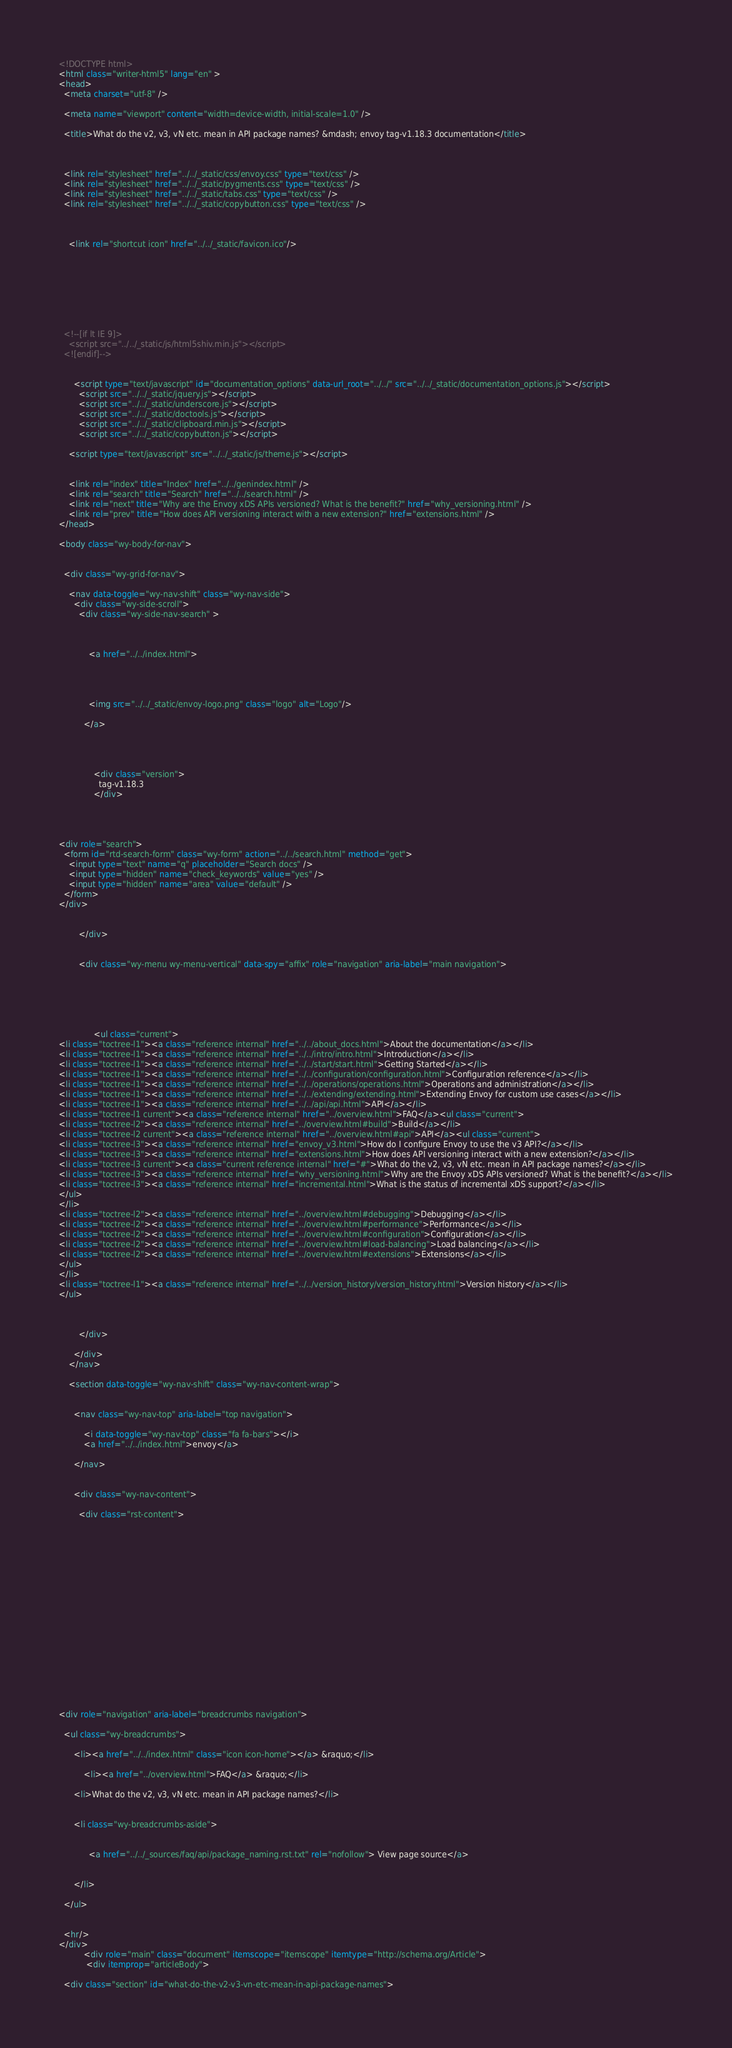<code> <loc_0><loc_0><loc_500><loc_500><_HTML_>

<!DOCTYPE html>
<html class="writer-html5" lang="en" >
<head>
  <meta charset="utf-8" />
  
  <meta name="viewport" content="width=device-width, initial-scale=1.0" />
  
  <title>What do the v2, v3, vN etc. mean in API package names? &mdash; envoy tag-v1.18.3 documentation</title>
  

  
  <link rel="stylesheet" href="../../_static/css/envoy.css" type="text/css" />
  <link rel="stylesheet" href="../../_static/pygments.css" type="text/css" />
  <link rel="stylesheet" href="../../_static/tabs.css" type="text/css" />
  <link rel="stylesheet" href="../../_static/copybutton.css" type="text/css" />

  
  
    <link rel="shortcut icon" href="../../_static/favicon.ico"/>
  

  
  

  

  
  <!--[if lt IE 9]>
    <script src="../../_static/js/html5shiv.min.js"></script>
  <![endif]-->
  
    
      <script type="text/javascript" id="documentation_options" data-url_root="../../" src="../../_static/documentation_options.js"></script>
        <script src="../../_static/jquery.js"></script>
        <script src="../../_static/underscore.js"></script>
        <script src="../../_static/doctools.js"></script>
        <script src="../../_static/clipboard.min.js"></script>
        <script src="../../_static/copybutton.js"></script>
    
    <script type="text/javascript" src="../../_static/js/theme.js"></script>

    
    <link rel="index" title="Index" href="../../genindex.html" />
    <link rel="search" title="Search" href="../../search.html" />
    <link rel="next" title="Why are the Envoy xDS APIs versioned? What is the benefit?" href="why_versioning.html" />
    <link rel="prev" title="How does API versioning interact with a new extension?" href="extensions.html" /> 
</head>

<body class="wy-body-for-nav">

   
  <div class="wy-grid-for-nav">
    
    <nav data-toggle="wy-nav-shift" class="wy-nav-side">
      <div class="wy-side-scroll">
        <div class="wy-side-nav-search" >
          

          
            <a href="../../index.html">
          

          
            
            <img src="../../_static/envoy-logo.png" class="logo" alt="Logo"/>
          
          </a>

          
            
            
              <div class="version">
                tag-v1.18.3
              </div>
            
          

          
<div role="search">
  <form id="rtd-search-form" class="wy-form" action="../../search.html" method="get">
    <input type="text" name="q" placeholder="Search docs" />
    <input type="hidden" name="check_keywords" value="yes" />
    <input type="hidden" name="area" value="default" />
  </form>
</div>

          
        </div>

        
        <div class="wy-menu wy-menu-vertical" data-spy="affix" role="navigation" aria-label="main navigation">
          
            
            
              
            
            
              <ul class="current">
<li class="toctree-l1"><a class="reference internal" href="../../about_docs.html">About the documentation</a></li>
<li class="toctree-l1"><a class="reference internal" href="../../intro/intro.html">Introduction</a></li>
<li class="toctree-l1"><a class="reference internal" href="../../start/start.html">Getting Started</a></li>
<li class="toctree-l1"><a class="reference internal" href="../../configuration/configuration.html">Configuration reference</a></li>
<li class="toctree-l1"><a class="reference internal" href="../../operations/operations.html">Operations and administration</a></li>
<li class="toctree-l1"><a class="reference internal" href="../../extending/extending.html">Extending Envoy for custom use cases</a></li>
<li class="toctree-l1"><a class="reference internal" href="../../api/api.html">API</a></li>
<li class="toctree-l1 current"><a class="reference internal" href="../overview.html">FAQ</a><ul class="current">
<li class="toctree-l2"><a class="reference internal" href="../overview.html#build">Build</a></li>
<li class="toctree-l2 current"><a class="reference internal" href="../overview.html#api">API</a><ul class="current">
<li class="toctree-l3"><a class="reference internal" href="envoy_v3.html">How do I configure Envoy to use the v3 API?</a></li>
<li class="toctree-l3"><a class="reference internal" href="extensions.html">How does API versioning interact with a new extension?</a></li>
<li class="toctree-l3 current"><a class="current reference internal" href="#">What do the v2, v3, vN etc. mean in API package names?</a></li>
<li class="toctree-l3"><a class="reference internal" href="why_versioning.html">Why are the Envoy xDS APIs versioned? What is the benefit?</a></li>
<li class="toctree-l3"><a class="reference internal" href="incremental.html">What is the status of incremental xDS support?</a></li>
</ul>
</li>
<li class="toctree-l2"><a class="reference internal" href="../overview.html#debugging">Debugging</a></li>
<li class="toctree-l2"><a class="reference internal" href="../overview.html#performance">Performance</a></li>
<li class="toctree-l2"><a class="reference internal" href="../overview.html#configuration">Configuration</a></li>
<li class="toctree-l2"><a class="reference internal" href="../overview.html#load-balancing">Load balancing</a></li>
<li class="toctree-l2"><a class="reference internal" href="../overview.html#extensions">Extensions</a></li>
</ul>
</li>
<li class="toctree-l1"><a class="reference internal" href="../../version_history/version_history.html">Version history</a></li>
</ul>

            
          
        </div>
        
      </div>
    </nav>

    <section data-toggle="wy-nav-shift" class="wy-nav-content-wrap">

      
      <nav class="wy-nav-top" aria-label="top navigation">
        
          <i data-toggle="wy-nav-top" class="fa fa-bars"></i>
          <a href="../../index.html">envoy</a>
        
      </nav>


      <div class="wy-nav-content">
        
        <div class="rst-content">
        
          

















<div role="navigation" aria-label="breadcrumbs navigation">

  <ul class="wy-breadcrumbs">
    
      <li><a href="../../index.html" class="icon icon-home"></a> &raquo;</li>
        
          <li><a href="../overview.html">FAQ</a> &raquo;</li>
        
      <li>What do the v2, v3, vN etc. mean in API package names?</li>
    
    
      <li class="wy-breadcrumbs-aside">
        
          
            <a href="../../_sources/faq/api/package_naming.rst.txt" rel="nofollow"> View page source</a>
          
        
      </li>
    
  </ul>

  
  <hr/>
</div>
          <div role="main" class="document" itemscope="itemscope" itemtype="http://schema.org/Article">
           <div itemprop="articleBody">
            
  <div class="section" id="what-do-the-v2-v3-vn-etc-mean-in-api-package-names"></code> 